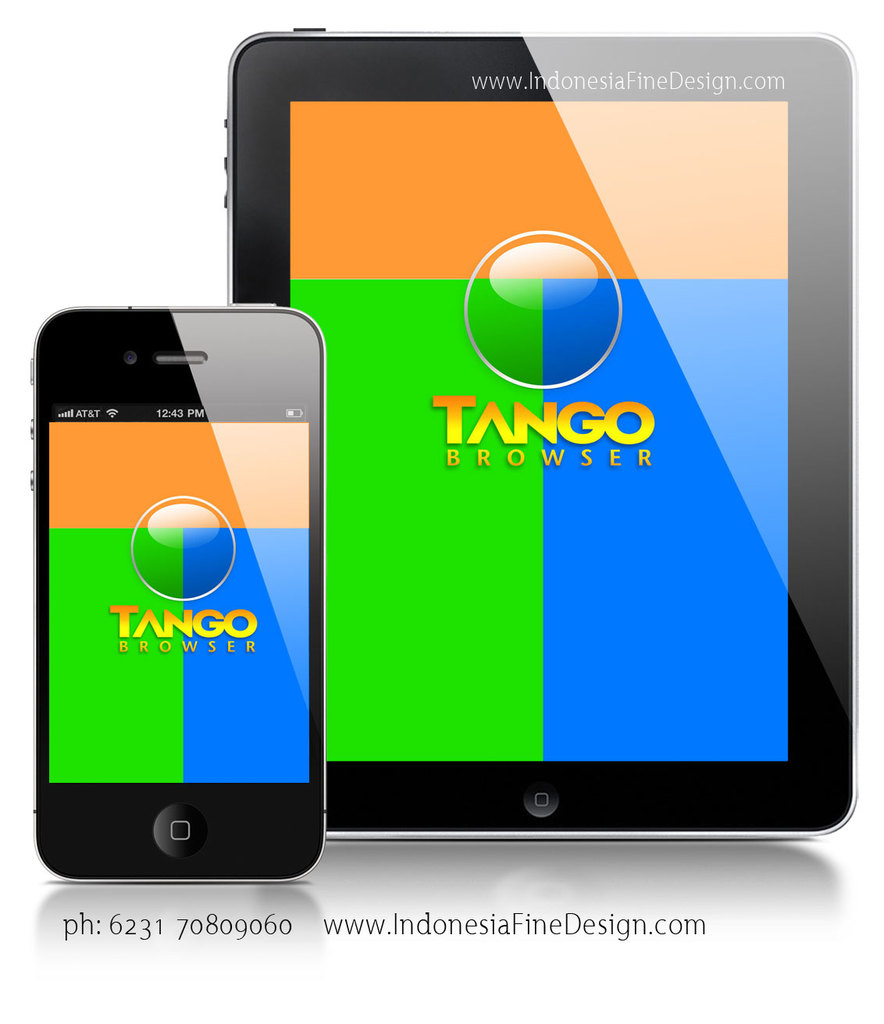Can you explain the color selections in the marketing materials for the Tango Browser as seen on the devices? The striking use of contrasting colors—vibrant oranges and blues alongside greens—within the Tango Browser's design as shown in the image, seems intentionally vibrant to catch the user's eye, suggesting a modern and lively brand personality. Such colors likely aim to convey energy and efficiency, reinforcing the browser's promise of speed and performance. 